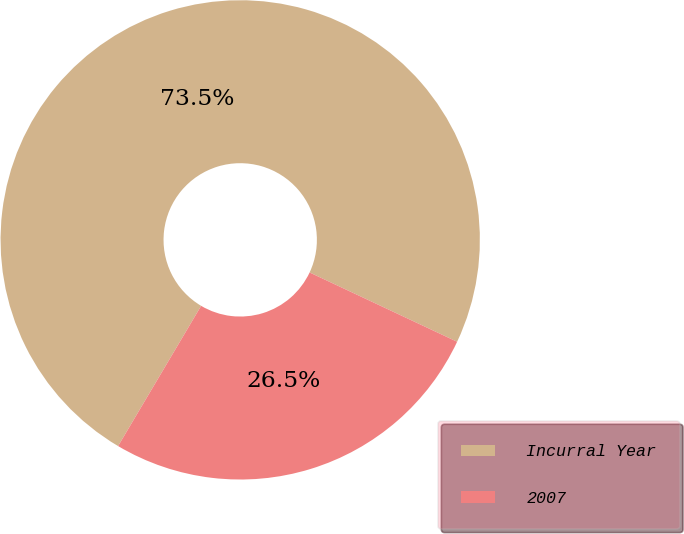Convert chart. <chart><loc_0><loc_0><loc_500><loc_500><pie_chart><fcel>Incurral Year<fcel>2007<nl><fcel>73.48%<fcel>26.52%<nl></chart> 